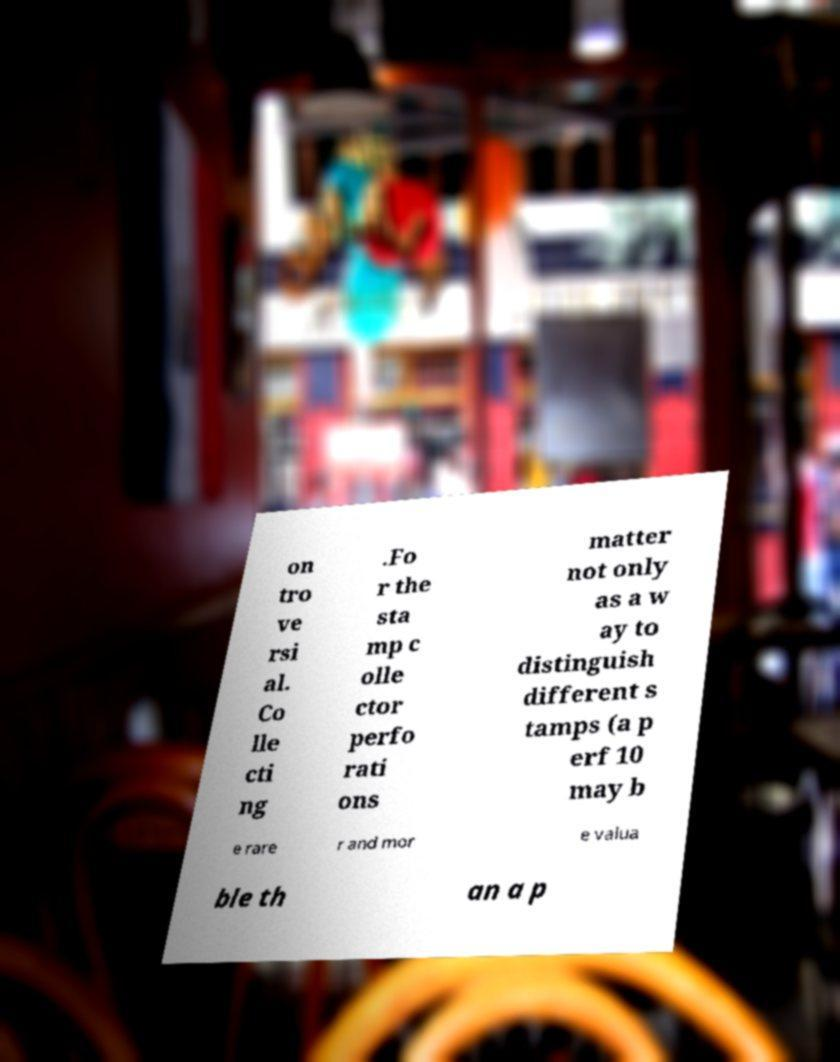Could you assist in decoding the text presented in this image and type it out clearly? on tro ve rsi al. Co lle cti ng .Fo r the sta mp c olle ctor perfo rati ons matter not only as a w ay to distinguish different s tamps (a p erf 10 may b e rare r and mor e valua ble th an a p 